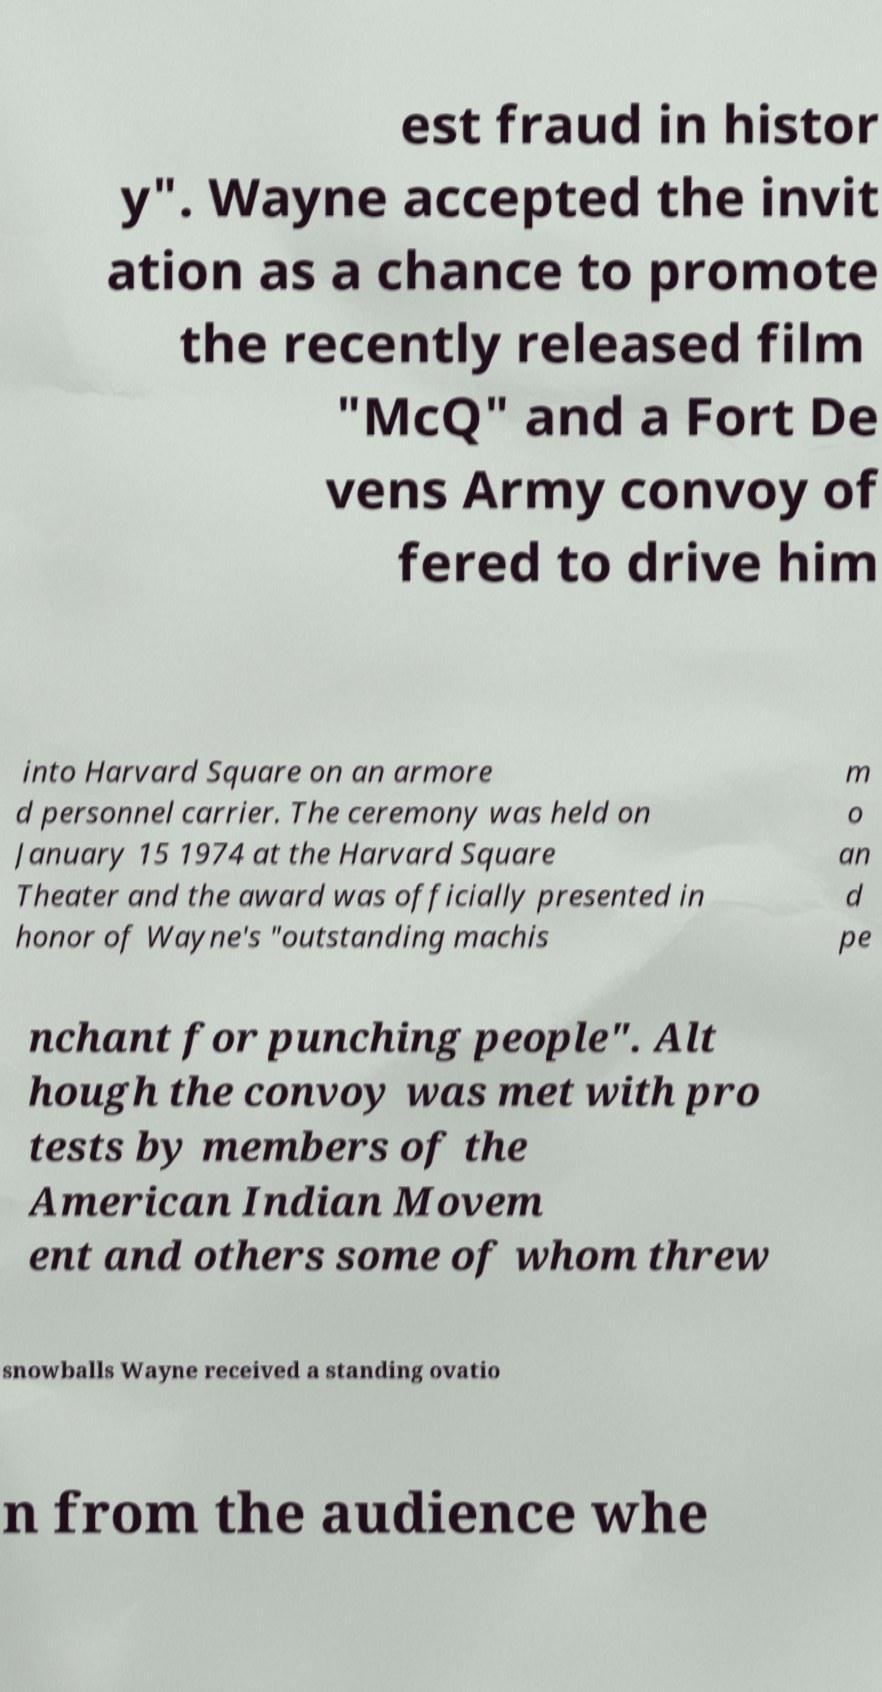There's text embedded in this image that I need extracted. Can you transcribe it verbatim? est fraud in histor y". Wayne accepted the invit ation as a chance to promote the recently released film "McQ" and a Fort De vens Army convoy of fered to drive him into Harvard Square on an armore d personnel carrier. The ceremony was held on January 15 1974 at the Harvard Square Theater and the award was officially presented in honor of Wayne's "outstanding machis m o an d pe nchant for punching people". Alt hough the convoy was met with pro tests by members of the American Indian Movem ent and others some of whom threw snowballs Wayne received a standing ovatio n from the audience whe 